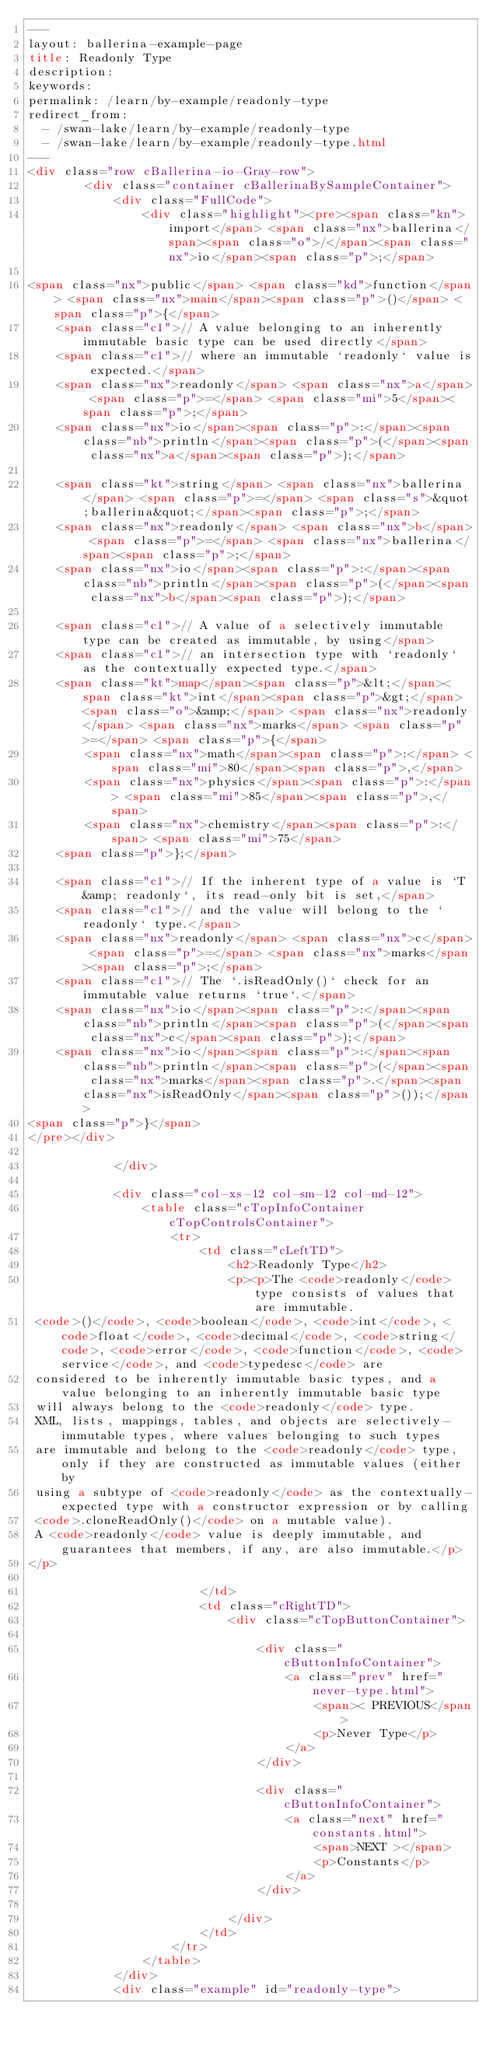<code> <loc_0><loc_0><loc_500><loc_500><_HTML_>---
layout: ballerina-example-page
title: Readonly Type
description: 
keywords: 
permalink: /learn/by-example/readonly-type
redirect_from:
  - /swan-lake/learn/by-example/readonly-type
  - /swan-lake/learn/by-example/readonly-type.html
---
<div class="row cBallerina-io-Gray-row">
        <div class="container cBallerinaBySampleContainer">
            <div class="FullCode">
                <div class="highlight"><pre><span class="kn">import</span> <span class="nx">ballerina</span><span class="o">/</span><span class="nx">io</span><span class="p">;</span>

<span class="nx">public</span> <span class="kd">function</span> <span class="nx">main</span><span class="p">()</span> <span class="p">{</span>
    <span class="c1">// A value belonging to an inherently immutable basic type can be used directly</span>
    <span class="c1">// where an immutable `readonly` value is expected.</span>
    <span class="nx">readonly</span> <span class="nx">a</span> <span class="p">=</span> <span class="mi">5</span><span class="p">;</span>
    <span class="nx">io</span><span class="p">:</span><span class="nb">println</span><span class="p">(</span><span class="nx">a</span><span class="p">);</span>

    <span class="kt">string</span> <span class="nx">ballerina</span> <span class="p">=</span> <span class="s">&quot;ballerina&quot;</span><span class="p">;</span>
    <span class="nx">readonly</span> <span class="nx">b</span> <span class="p">=</span> <span class="nx">ballerina</span><span class="p">;</span>
    <span class="nx">io</span><span class="p">:</span><span class="nb">println</span><span class="p">(</span><span class="nx">b</span><span class="p">);</span>

    <span class="c1">// A value of a selectively immutable type can be created as immutable, by using</span>
    <span class="c1">// an intersection type with `readonly` as the contextually expected type.</span>
    <span class="kt">map</span><span class="p">&lt;</span><span class="kt">int</span><span class="p">&gt;</span> <span class="o">&amp;</span> <span class="nx">readonly</span> <span class="nx">marks</span> <span class="p">=</span> <span class="p">{</span>
        <span class="nx">math</span><span class="p">:</span> <span class="mi">80</span><span class="p">,</span>
        <span class="nx">physics</span><span class="p">:</span> <span class="mi">85</span><span class="p">,</span>
        <span class="nx">chemistry</span><span class="p">:</span> <span class="mi">75</span>
    <span class="p">};</span>

    <span class="c1">// If the inherent type of a value is `T &amp; readonly`, its read-only bit is set,</span>
    <span class="c1">// and the value will belong to the `readonly` type.</span>
    <span class="nx">readonly</span> <span class="nx">c</span> <span class="p">=</span> <span class="nx">marks</span><span class="p">;</span>
    <span class="c1">// The `.isReadOnly()` check for an immutable value returns `true`.</span>
    <span class="nx">io</span><span class="p">:</span><span class="nb">println</span><span class="p">(</span><span class="nx">c</span><span class="p">);</span>
    <span class="nx">io</span><span class="p">:</span><span class="nb">println</span><span class="p">(</span><span class="nx">marks</span><span class="p">.</span><span class="nx">isReadOnly</span><span class="p">());</span>
<span class="p">}</span>
</pre></div>

            </div>

            <div class="col-xs-12 col-sm-12 col-md-12">
                <table class="cTopInfoContainer cTopControlsContainer">
                    <tr>
                        <td class="cLeftTD">
                            <h2>Readonly Type</h2>
                            <p><p>The <code>readonly</code> type consists of values that are immutable.
 <code>()</code>, <code>boolean</code>, <code>int</code>, <code>float</code>, <code>decimal</code>, <code>string</code>, <code>error</code>, <code>function</code>, <code>service</code>, and <code>typedesc</code> are
 considered to be inherently immutable basic types, and a value belonging to an inherently immutable basic type
 will always belong to the <code>readonly</code> type.
 XML, lists, mappings, tables, and objects are selectively-immutable types, where values belonging to such types
 are immutable and belong to the <code>readonly</code> type, only if they are constructed as immutable values (either by
 using a subtype of <code>readonly</code> as the contextually-expected type with a constructor expression or by calling
 <code>.cloneReadOnly()</code> on a mutable value).
 A <code>readonly</code> value is deeply immutable, and guarantees that members, if any, are also immutable.</p>
</p>

                        </td>
                        <td class="cRightTD">
                            <div class="cTopButtonContainer">
                                
                                <div class="cButtonInfoContainer">
                                    <a class="prev" href="never-type.html">
                                        <span>< PREVIOUS</span>
                                        <p>Never Type</p>
                                    </a>
                                </div>
                                 
                                <div class="cButtonInfoContainer">
                                    <a class="next" href="constants.html">
                                        <span>NEXT ></span>
                                        <p>Constants</p>
                                    </a>
                                </div>
                                
                            </div>
                        </td>
                    </tr>
                </table>
            </div>
            <div class="example" id="readonly-type"></code> 